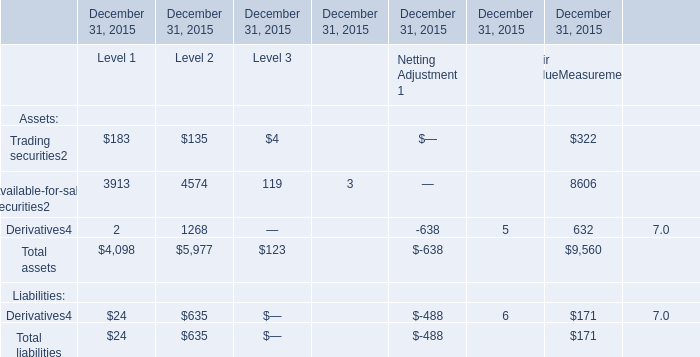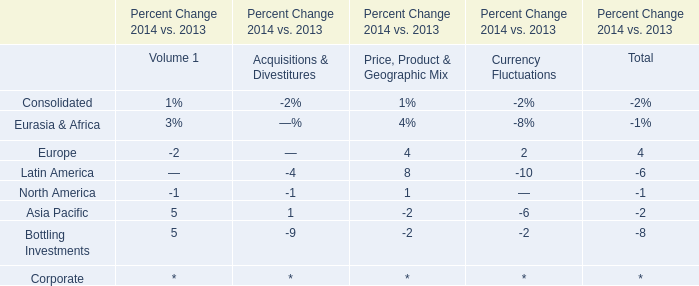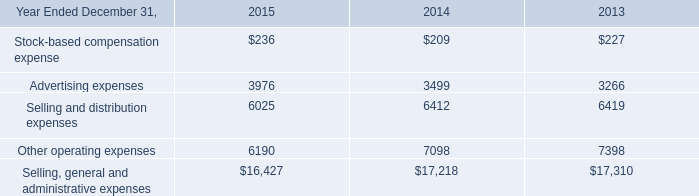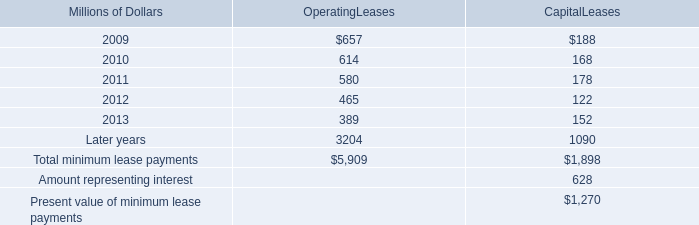what was the ratio of the rent expense for operating leases with terms exceeding one month in 2008 to 2007 
Computations: (747 / 810)
Answer: 0.92222. 